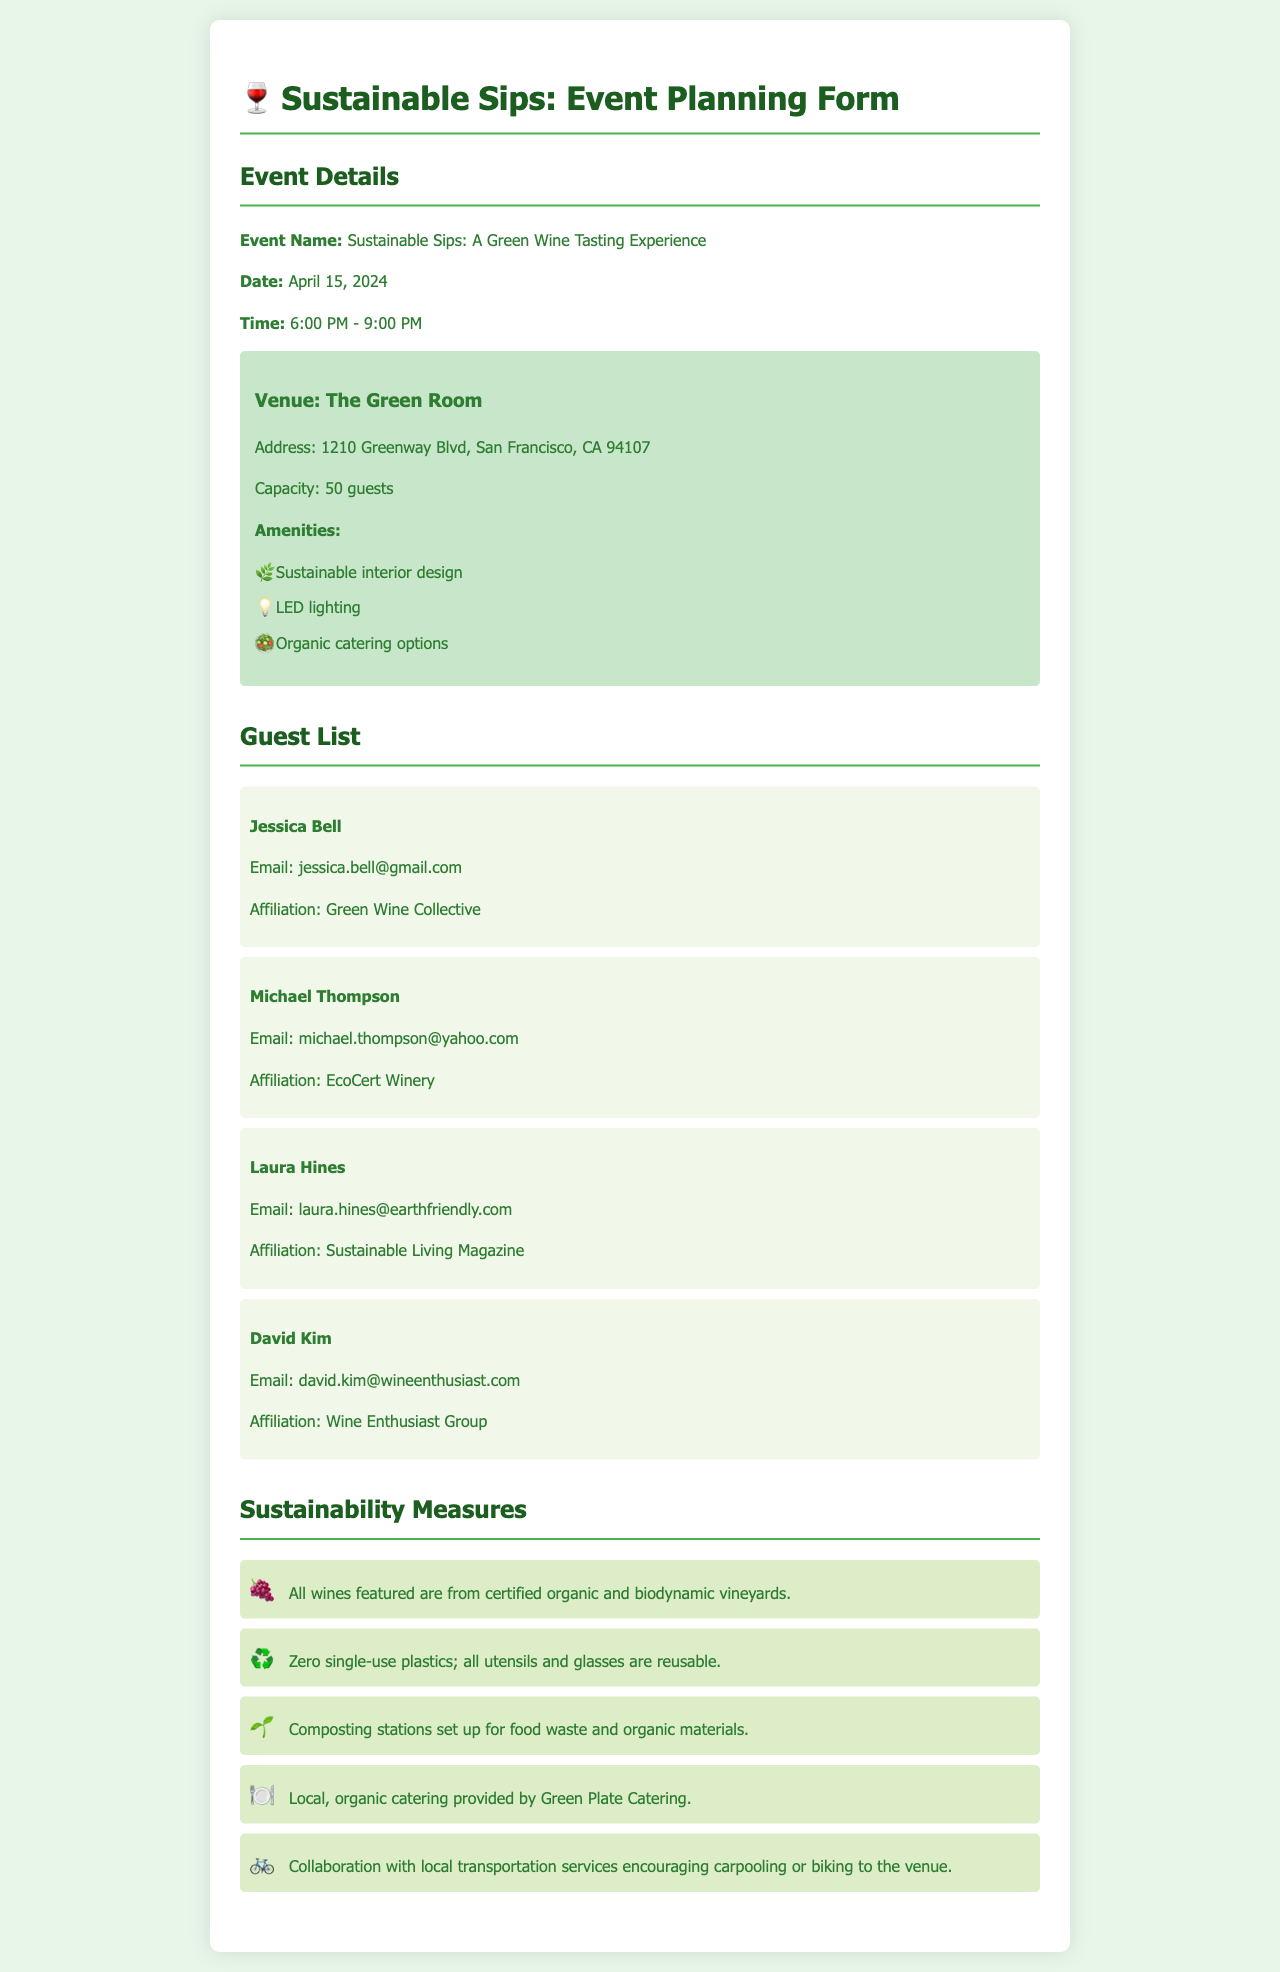what is the event name? The event name is provided in the document under "Event Details" as the title of the event.
Answer: Sustainable Sips: A Green Wine Tasting Experience when is the event scheduled? The date is specified in the "Event Details" section, indicating when the event will take place.
Answer: April 15, 2024 what is the venue's address? The address of the venue is located in the venue information section of the document.
Answer: 1210 Greenway Blvd, San Francisco, CA 94107 who is the guest affiliated with EcoCert Winery? The document lists guests and their affiliations, making it easy to identify specific guests.
Answer: Michael Thompson how many guests can the venue accommodate? This information is found in the venue details where the capacity of the venue is mentioned.
Answer: 50 guests what type of catering is provided at the event? The catering type is mentioned in the sustainability measures section, indicating the nature of the catering service.
Answer: Organic catering what sustainability measure is being implemented for waste? Several sustainability measures are listed, and one specifically addresses food waste management.
Answer: Composting stations how will guests be encouraged to travel to the venue? The document outlines collaborative efforts for transportation under sustainability measures, highlighting how guests are encouraged to travel.
Answer: Carpooling or biking which organization is handling the catering? The hospitality service for the event is specified in the sustainability measures along with the nature of the catering.
Answer: Green Plate Catering 